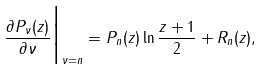<formula> <loc_0><loc_0><loc_500><loc_500>\frac { \partial P _ { \nu } ( z ) } { \partial \nu } \Big | _ { \nu = n } = P _ { n } ( z ) \ln \frac { z + 1 } { 2 } + R _ { n } ( z ) ,</formula> 